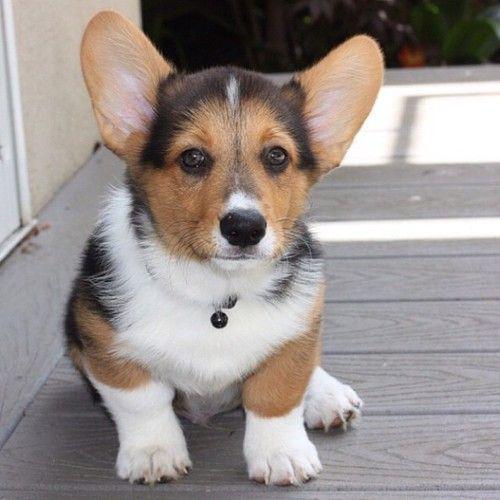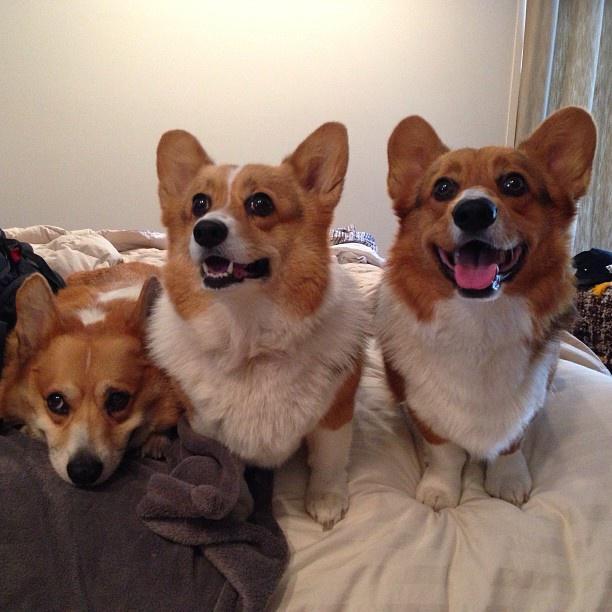The first image is the image on the left, the second image is the image on the right. Considering the images on both sides, is "There are four dogs." valid? Answer yes or no. Yes. The first image is the image on the left, the second image is the image on the right. Considering the images on both sides, is "There are three dogs in the right image." valid? Answer yes or no. Yes. 